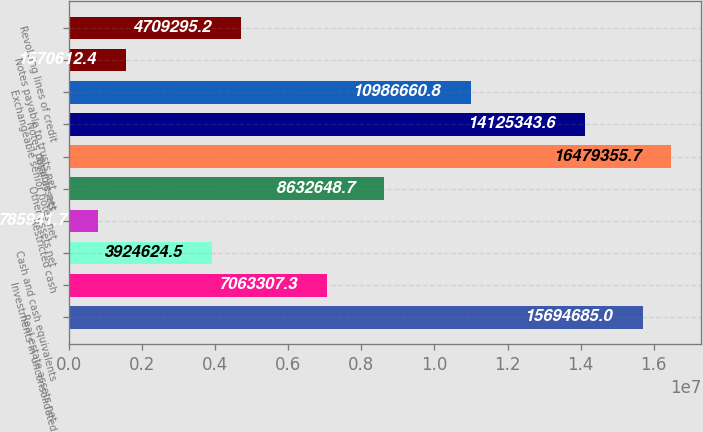Convert chart. <chart><loc_0><loc_0><loc_500><loc_500><bar_chart><fcel>Real estate assets net<fcel>Investments in unconsolidated<fcel>Cash and cash equivalents<fcel>Restricted cash<fcel>Other assets net<fcel>Total assets<fcel>Notes payable net<fcel>Exchangeable senior notes net<fcel>Notes payable to trusts net<fcel>Revolving lines of credit<nl><fcel>1.56947e+07<fcel>7.06331e+06<fcel>3.92462e+06<fcel>785942<fcel>8.63265e+06<fcel>1.64794e+07<fcel>1.41253e+07<fcel>1.09867e+07<fcel>1.57061e+06<fcel>4.7093e+06<nl></chart> 